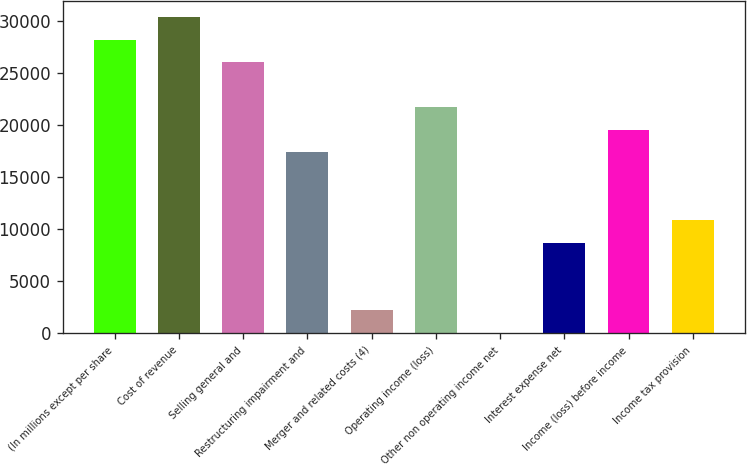<chart> <loc_0><loc_0><loc_500><loc_500><bar_chart><fcel>(In millions except per share<fcel>Cost of revenue<fcel>Selling general and<fcel>Restructuring impairment and<fcel>Merger and related costs (4)<fcel>Operating income (loss)<fcel>Other non operating income net<fcel>Interest expense net<fcel>Income (loss) before income<fcel>Income tax provision<nl><fcel>28229.2<fcel>30398.6<fcel>26059.8<fcel>17382.2<fcel>2196.4<fcel>21721<fcel>27<fcel>8704.6<fcel>19551.6<fcel>10874<nl></chart> 